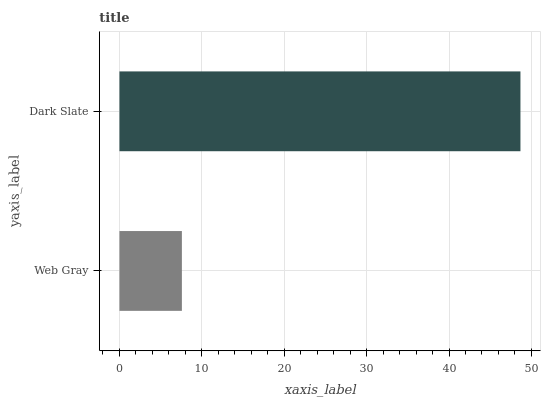Is Web Gray the minimum?
Answer yes or no. Yes. Is Dark Slate the maximum?
Answer yes or no. Yes. Is Dark Slate the minimum?
Answer yes or no. No. Is Dark Slate greater than Web Gray?
Answer yes or no. Yes. Is Web Gray less than Dark Slate?
Answer yes or no. Yes. Is Web Gray greater than Dark Slate?
Answer yes or no. No. Is Dark Slate less than Web Gray?
Answer yes or no. No. Is Dark Slate the high median?
Answer yes or no. Yes. Is Web Gray the low median?
Answer yes or no. Yes. Is Web Gray the high median?
Answer yes or no. No. Is Dark Slate the low median?
Answer yes or no. No. 